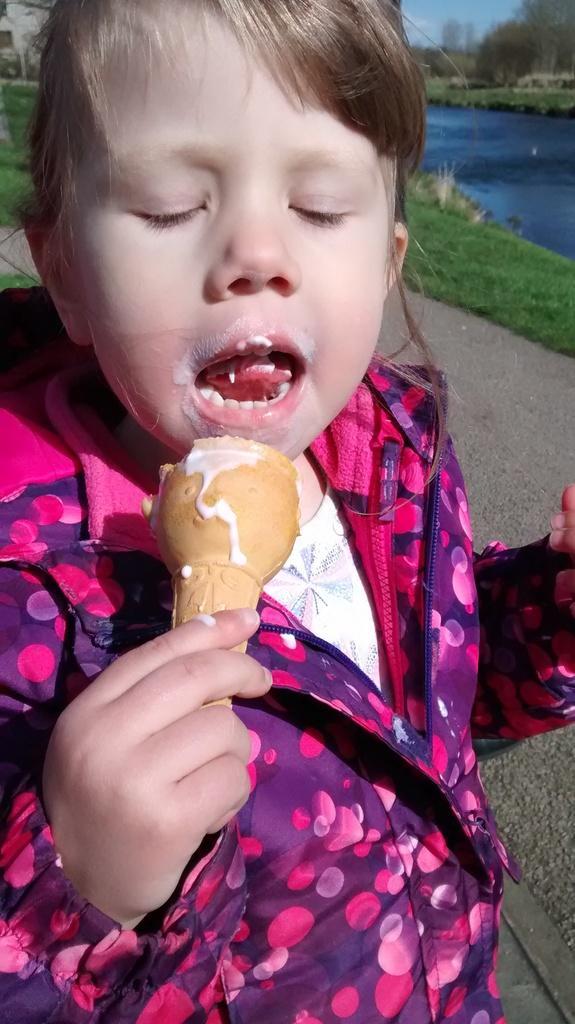Could you give a brief overview of what you see in this image? In this picture we can see a girl who is eating an ice cream. This is the road. There is grass and this is water. Even we can see the sky here. 